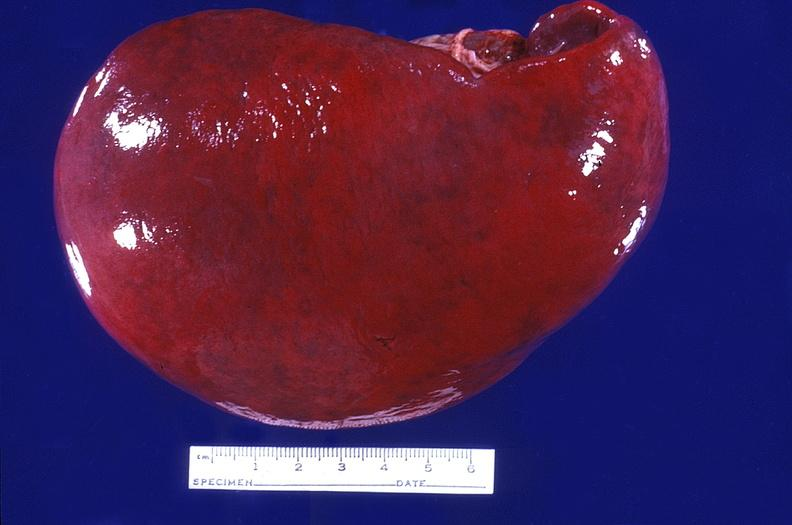what is present?
Answer the question using a single word or phrase. Hematologic 